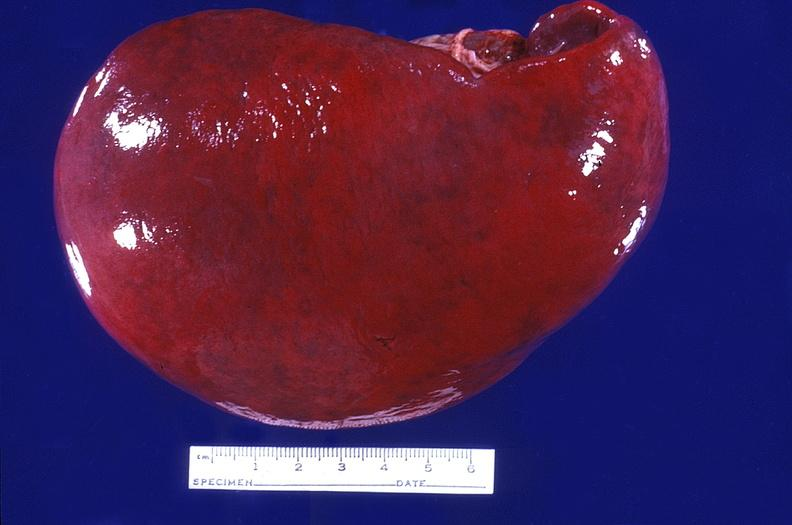what is present?
Answer the question using a single word or phrase. Hematologic 